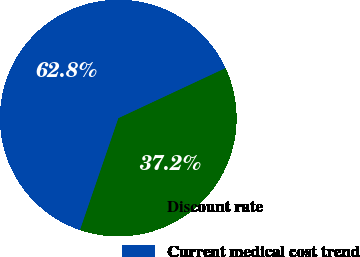<chart> <loc_0><loc_0><loc_500><loc_500><pie_chart><fcel>Discount rate<fcel>Current medical cost trend<nl><fcel>37.22%<fcel>62.78%<nl></chart> 